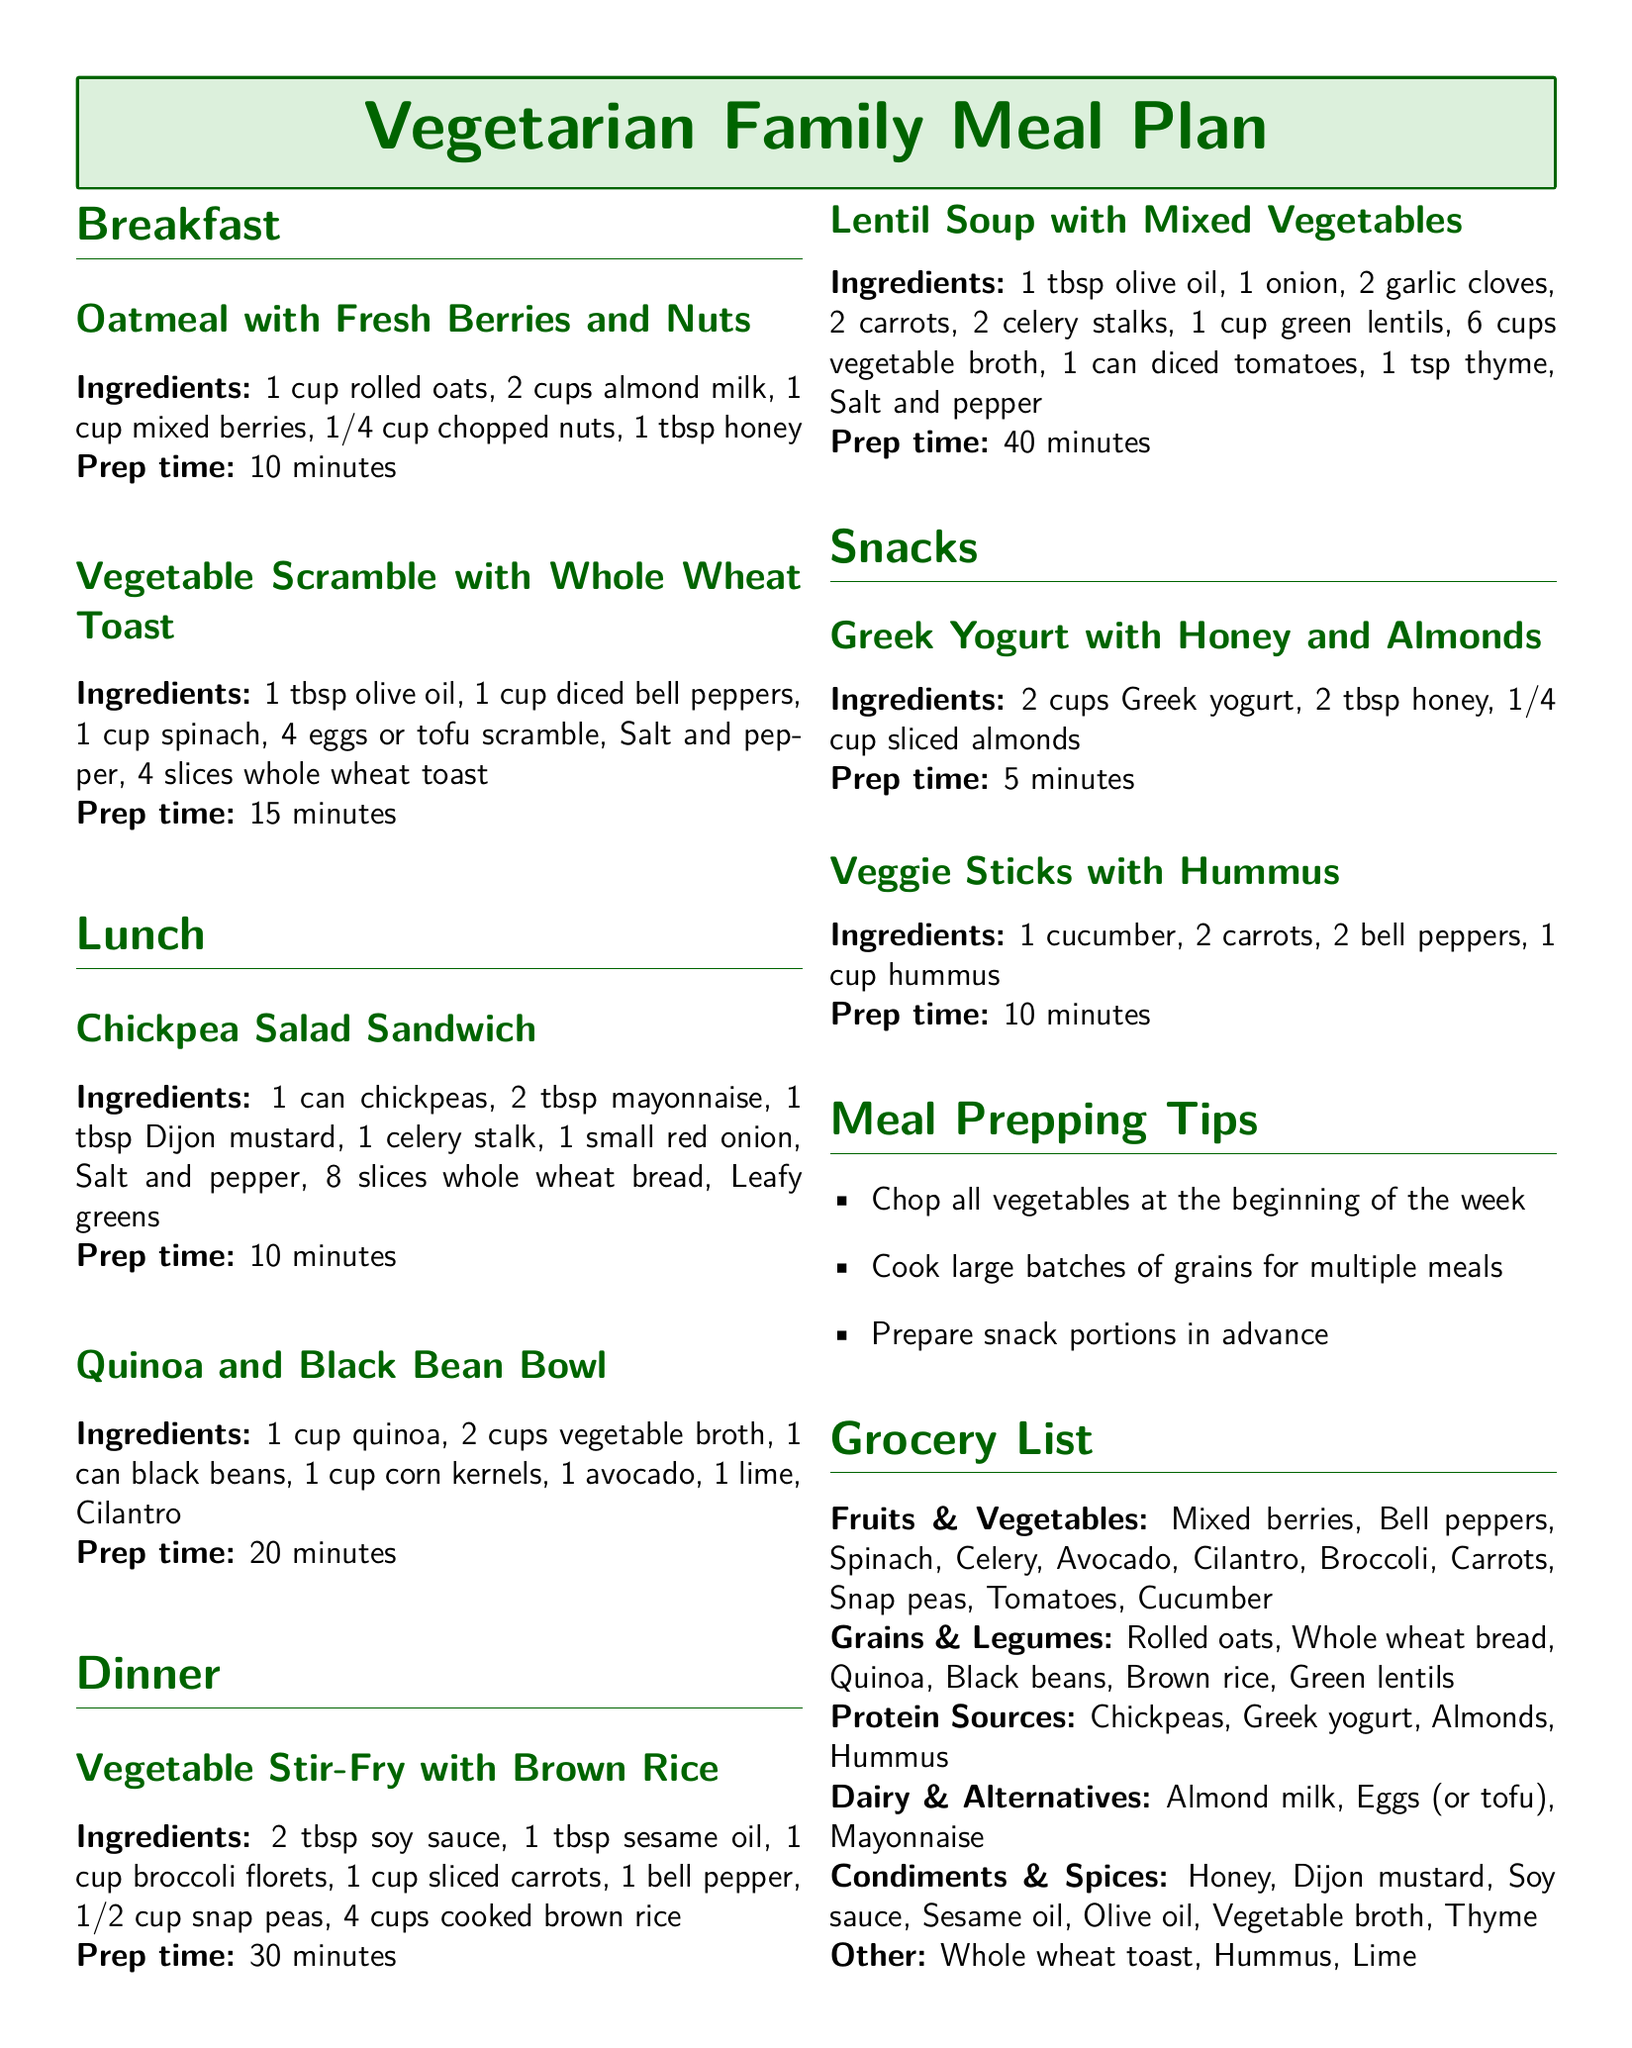What are the ingredients for the oatmeal? The ingredients for oatmeal include rolled oats, almond milk, mixed berries, chopped nuts, and honey.
Answer: Rolled oats, almond milk, mixed berries, chopped nuts, honey What is the prep time for the vegetable stir-fry? The prep time for the vegetable stir-fry is mentioned in the dinner section of the document, which is 30 minutes.
Answer: 30 minutes How many eggs are needed for the vegetable scramble? The vegetable scramble recipe specifies using 4 eggs or tofu scramble, which is indicated in the breakfast section.
Answer: 4 eggs What is a snack option listed in the meal plan? The document lists Greek yogurt with honey and almonds as a snack option.
Answer: Greek yogurt with honey and almonds What protein sources are included in the grocery list? The grocery list specifies several protein sources, which are chickpeas, Greek yogurt, almonds, and hummus.
Answer: Chickpeas, Greek yogurt, almonds, hummus What is one of the meal prepping tips? The meal prepping tips suggest chopping all vegetables at the beginning of the week, which is available in the tips section.
Answer: Chop all vegetables at the beginning of the week How many cups of vegetable broth are needed for the lentil soup? The recipe for lentil soup indicates the need for 6 cups of vegetable broth in the ingredients list.
Answer: 6 cups What is the main ingredient in the chickpea salad sandwich? The primary ingredient for the chickpea salad sandwich, as listed in the lunch section, is a can of chickpeas.
Answer: Can of chickpeas What type of milk is used in the oatmeal recipe? The document specifies that almond milk is the type of milk used in the oatmeal recipe found in the breakfast section.
Answer: Almond milk 